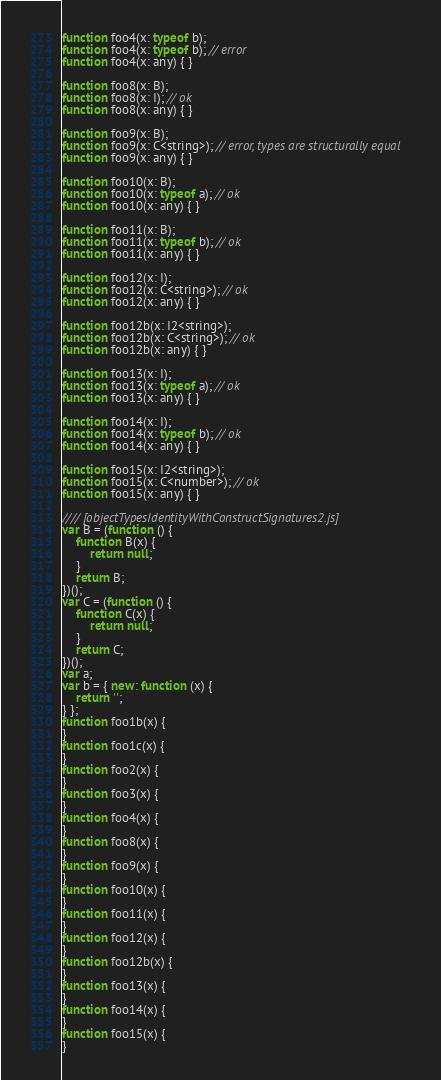<code> <loc_0><loc_0><loc_500><loc_500><_JavaScript_>function foo4(x: typeof b);
function foo4(x: typeof b); // error
function foo4(x: any) { }

function foo8(x: B);
function foo8(x: I); // ok
function foo8(x: any) { }

function foo9(x: B);
function foo9(x: C<string>); // error, types are structurally equal
function foo9(x: any) { }

function foo10(x: B);
function foo10(x: typeof a); // ok
function foo10(x: any) { }

function foo11(x: B);
function foo11(x: typeof b); // ok
function foo11(x: any) { }

function foo12(x: I);
function foo12(x: C<string>); // ok
function foo12(x: any) { }

function foo12b(x: I2<string>);
function foo12b(x: C<string>); // ok
function foo12b(x: any) { }

function foo13(x: I);
function foo13(x: typeof a); // ok
function foo13(x: any) { }

function foo14(x: I);
function foo14(x: typeof b); // ok
function foo14(x: any) { }

function foo15(x: I2<string>);
function foo15(x: C<number>); // ok
function foo15(x: any) { }

//// [objectTypesIdentityWithConstructSignatures2.js]
var B = (function () {
    function B(x) {
        return null;
    }
    return B;
})();
var C = (function () {
    function C(x) {
        return null;
    }
    return C;
})();
var a;
var b = { new: function (x) {
    return '';
} };
function foo1b(x) {
}
function foo1c(x) {
}
function foo2(x) {
}
function foo3(x) {
}
function foo4(x) {
}
function foo8(x) {
}
function foo9(x) {
}
function foo10(x) {
}
function foo11(x) {
}
function foo12(x) {
}
function foo12b(x) {
}
function foo13(x) {
}
function foo14(x) {
}
function foo15(x) {
}
</code> 